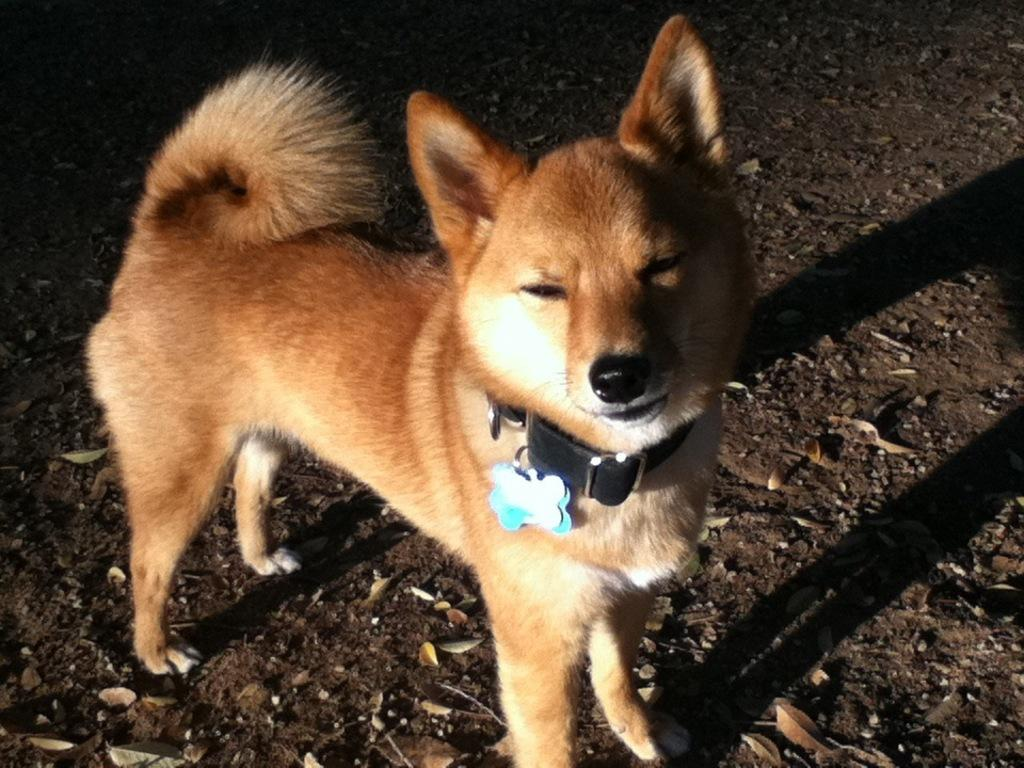What type of animal is in the picture? There is a brown dog in the picture. What color is the dog's leash? The dog's leash is black. What can be seen at the bottom of the image? The road and dry leaves are present at the bottom of the image. Where is the dog's shadow located in the image? The shadow of the dog is on the right side of the image. What type of brass instrument is the dog playing in the image? There is no brass instrument present in the image; it features a brown dog with a black leash. What color is the straw hat the dog is wearing in the image? There is no hat, including a straw hat, present in the image. 